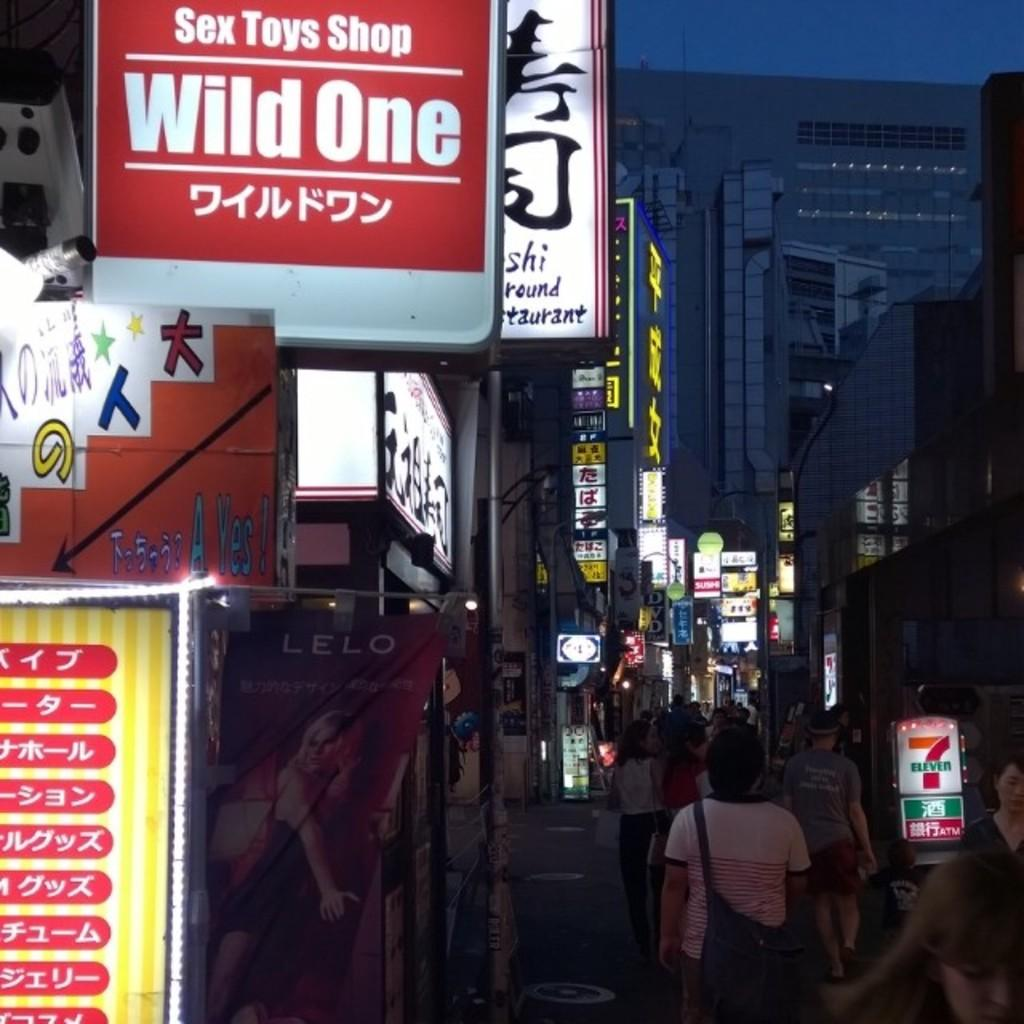<image>
Create a compact narrative representing the image presented. A shop called Wild One has a red sign over a busy sidewalk. 